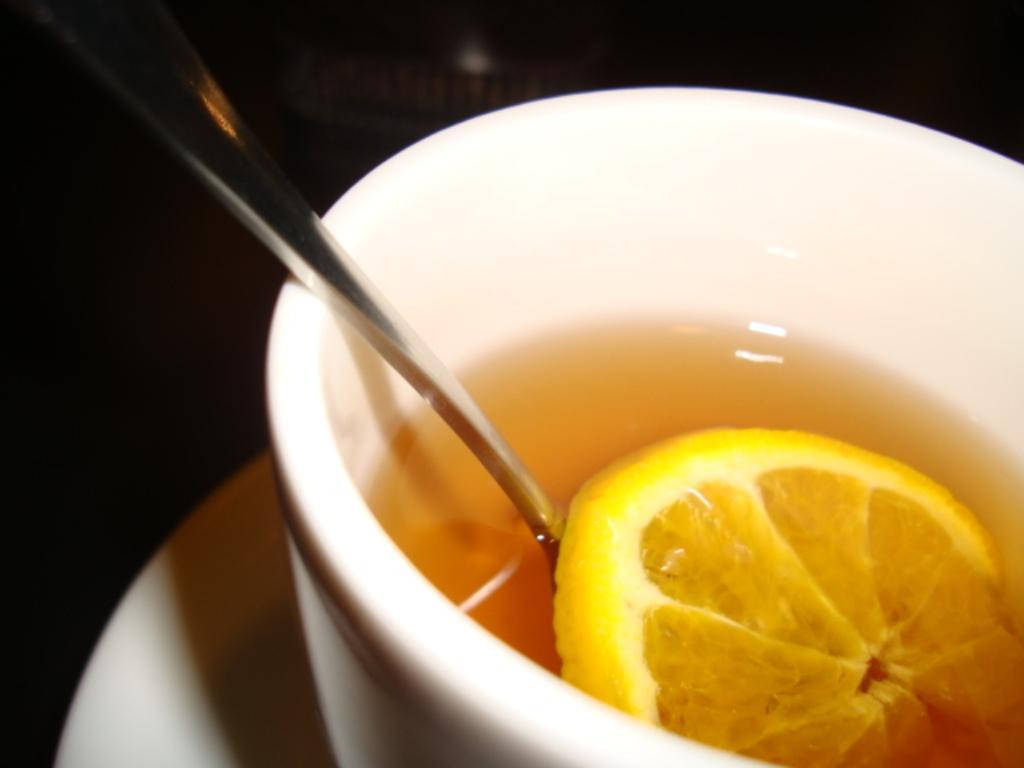Could you give a brief overview of what you see in this image? In the picture we can see a white color saucer on it, we can see a bowl in it, we can see a soup with a spoon and lemon slice in it. 